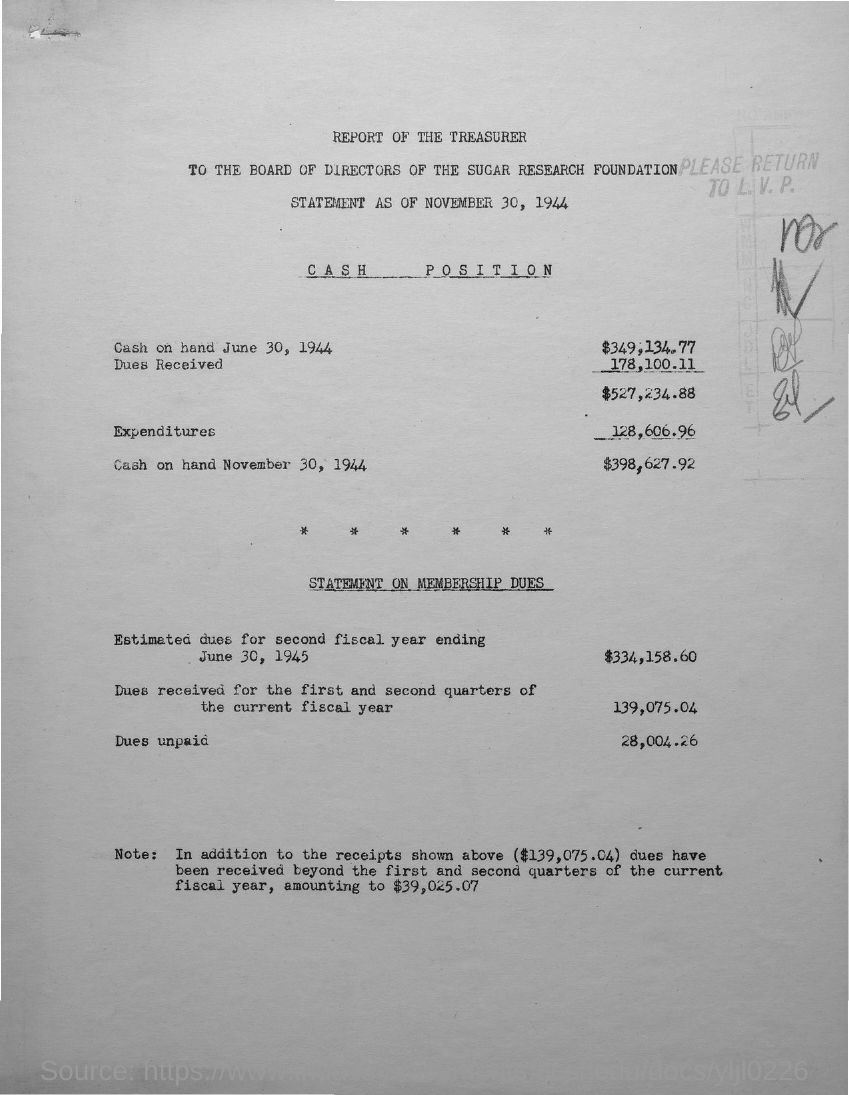What is the first title with an underline?
Make the answer very short. Cash Position. What is the second title with an underline?
Provide a short and direct response. Statement on membership dues. 